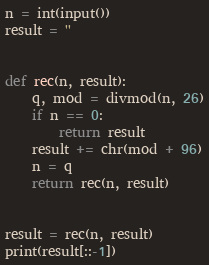Convert code to text. <code><loc_0><loc_0><loc_500><loc_500><_Python_>n = int(input())
result = ''


def rec(n, result):
    q, mod = divmod(n, 26)
    if n == 0:
        return result
    result += chr(mod + 96)
    n = q
    return rec(n, result)


result = rec(n, result)
print(result[::-1])
</code> 